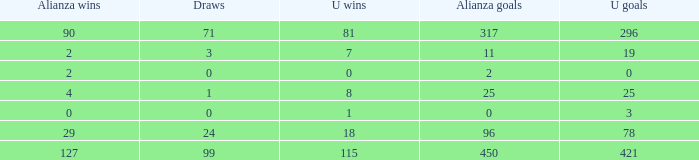What is the minimum u victories, when alianza triumphs is more than 0, when alianza scores is above 25, and when ties is "99"? 115.0. 